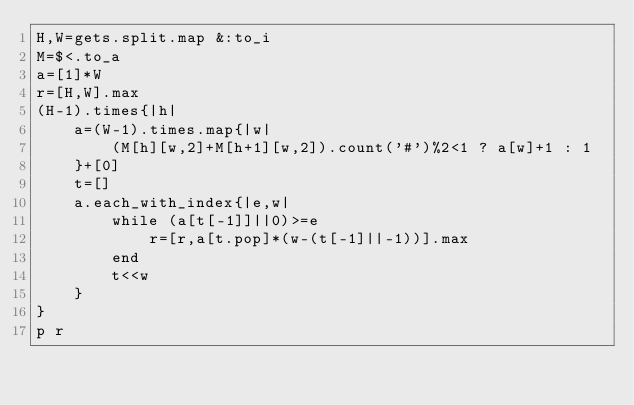Convert code to text. <code><loc_0><loc_0><loc_500><loc_500><_Ruby_>H,W=gets.split.map &:to_i
M=$<.to_a
a=[1]*W
r=[H,W].max
(H-1).times{|h|
	a=(W-1).times.map{|w|
		(M[h][w,2]+M[h+1][w,2]).count('#')%2<1 ? a[w]+1 : 1
	}+[0]
	t=[]
	a.each_with_index{|e,w|
		while (a[t[-1]]||0)>=e
			r=[r,a[t.pop]*(w-(t[-1]||-1))].max
		end
		t<<w
	}
}
p r</code> 